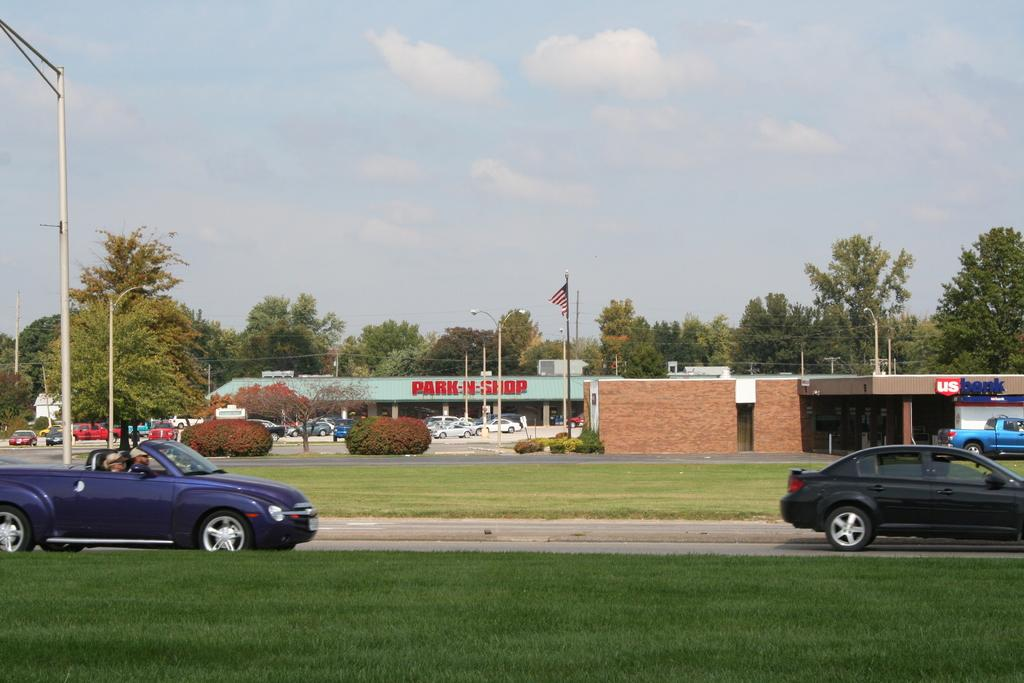What can be seen on the road in the image? There are cars on the road in the image. What is located in the background of the image? There is a garden, trees, poles, and cars visible in the background of the image. What else can be seen in the background of the image? Ships are visible in the background of the image. What part of the natural environment is visible in the image? The sky is visible in the image. What month is it in the image? The month cannot be determined from the image, as it does not contain any information about the time of year. What type of soda can be seen in the image? There is no soda present in the image. 